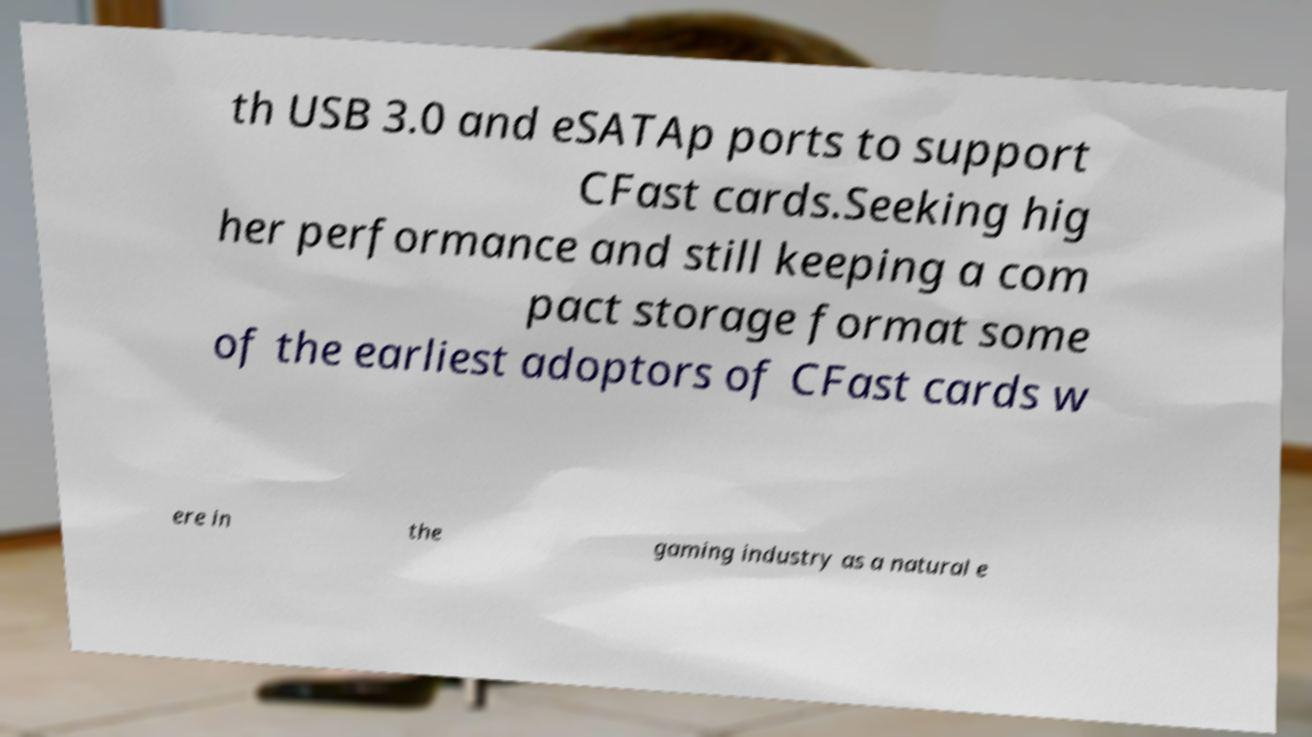Can you accurately transcribe the text from the provided image for me? th USB 3.0 and eSATAp ports to support CFast cards.Seeking hig her performance and still keeping a com pact storage format some of the earliest adoptors of CFast cards w ere in the gaming industry as a natural e 